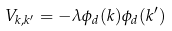<formula> <loc_0><loc_0><loc_500><loc_500>V _ { { k } , { k } ^ { \prime } } = - \lambda \phi _ { d } ( { k } ) \phi _ { d } ( { k } ^ { \prime } )</formula> 